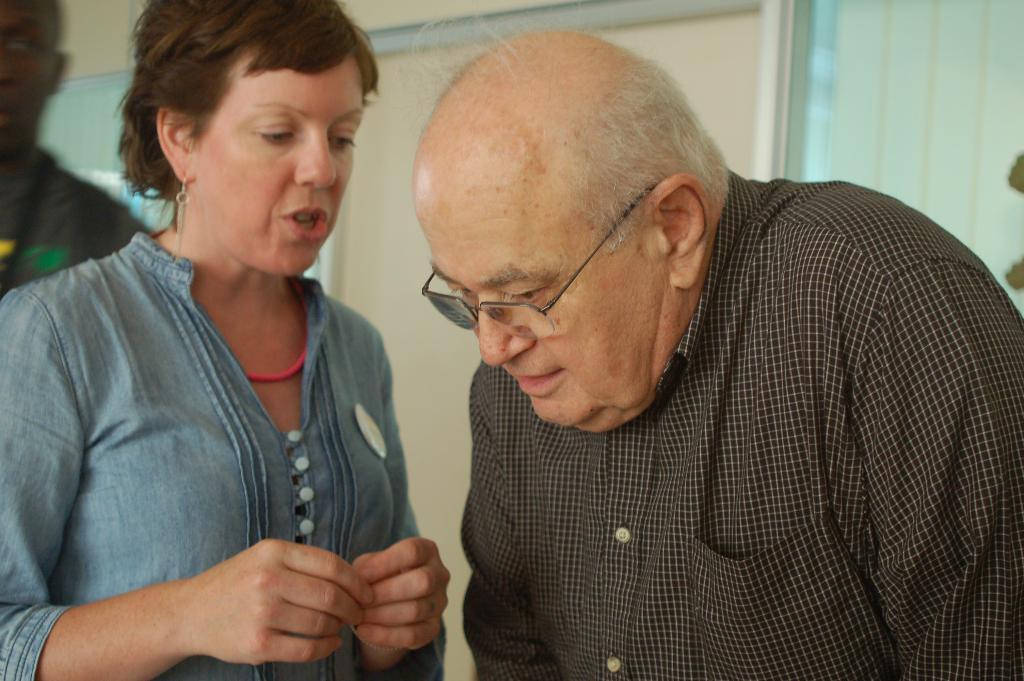Please provide a concise description of this image. In this picture we can see a man wore a spectacle and beside him a woman talking and in the background we can see a man, wall, curtain. 